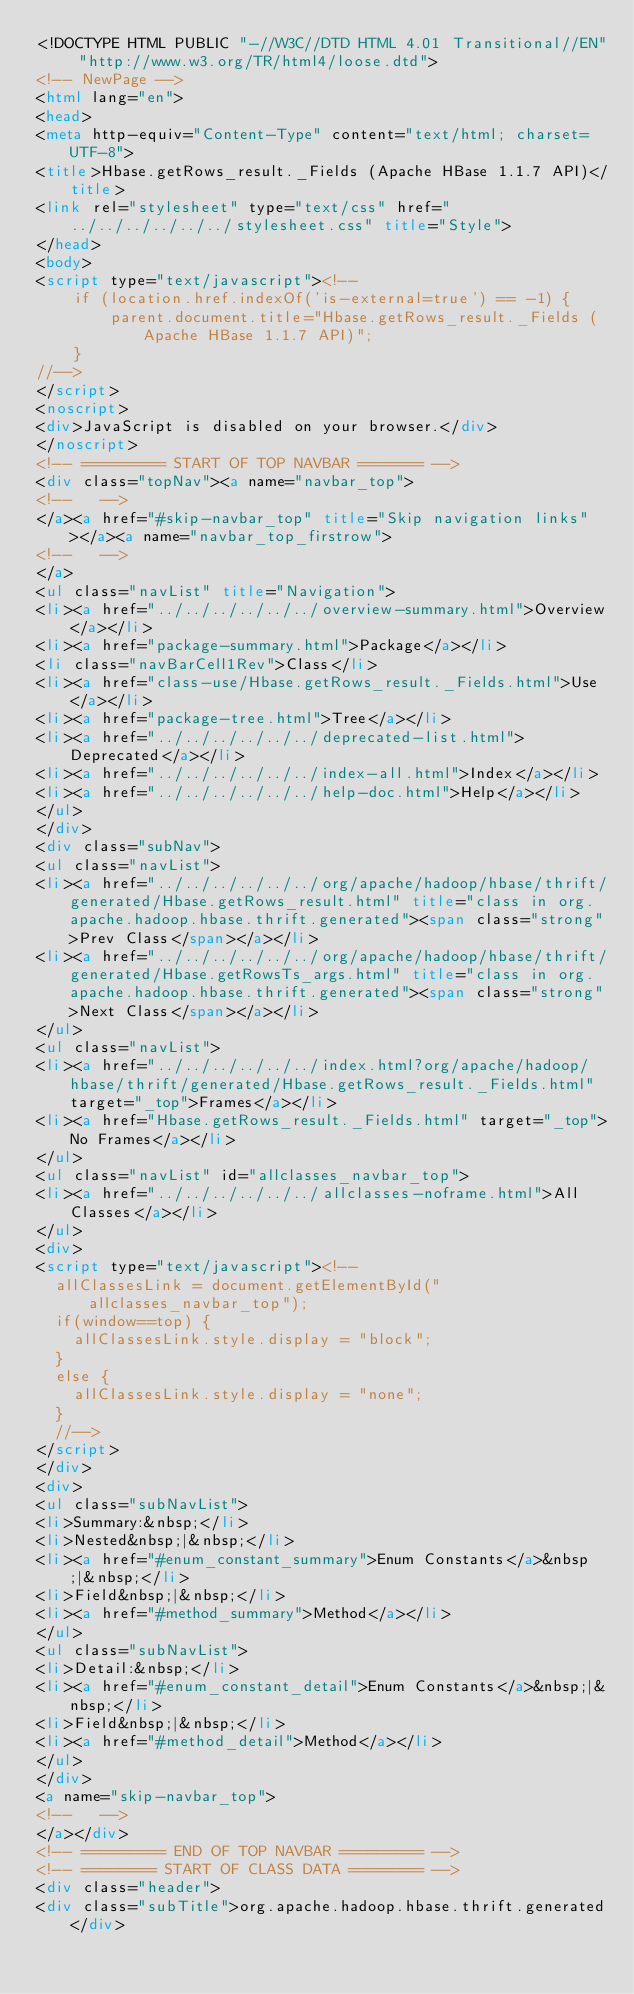<code> <loc_0><loc_0><loc_500><loc_500><_HTML_><!DOCTYPE HTML PUBLIC "-//W3C//DTD HTML 4.01 Transitional//EN" "http://www.w3.org/TR/html4/loose.dtd">
<!-- NewPage -->
<html lang="en">
<head>
<meta http-equiv="Content-Type" content="text/html; charset=UTF-8">
<title>Hbase.getRows_result._Fields (Apache HBase 1.1.7 API)</title>
<link rel="stylesheet" type="text/css" href="../../../../../../stylesheet.css" title="Style">
</head>
<body>
<script type="text/javascript"><!--
    if (location.href.indexOf('is-external=true') == -1) {
        parent.document.title="Hbase.getRows_result._Fields (Apache HBase 1.1.7 API)";
    }
//-->
</script>
<noscript>
<div>JavaScript is disabled on your browser.</div>
</noscript>
<!-- ========= START OF TOP NAVBAR ======= -->
<div class="topNav"><a name="navbar_top">
<!--   -->
</a><a href="#skip-navbar_top" title="Skip navigation links"></a><a name="navbar_top_firstrow">
<!--   -->
</a>
<ul class="navList" title="Navigation">
<li><a href="../../../../../../overview-summary.html">Overview</a></li>
<li><a href="package-summary.html">Package</a></li>
<li class="navBarCell1Rev">Class</li>
<li><a href="class-use/Hbase.getRows_result._Fields.html">Use</a></li>
<li><a href="package-tree.html">Tree</a></li>
<li><a href="../../../../../../deprecated-list.html">Deprecated</a></li>
<li><a href="../../../../../../index-all.html">Index</a></li>
<li><a href="../../../../../../help-doc.html">Help</a></li>
</ul>
</div>
<div class="subNav">
<ul class="navList">
<li><a href="../../../../../../org/apache/hadoop/hbase/thrift/generated/Hbase.getRows_result.html" title="class in org.apache.hadoop.hbase.thrift.generated"><span class="strong">Prev Class</span></a></li>
<li><a href="../../../../../../org/apache/hadoop/hbase/thrift/generated/Hbase.getRowsTs_args.html" title="class in org.apache.hadoop.hbase.thrift.generated"><span class="strong">Next Class</span></a></li>
</ul>
<ul class="navList">
<li><a href="../../../../../../index.html?org/apache/hadoop/hbase/thrift/generated/Hbase.getRows_result._Fields.html" target="_top">Frames</a></li>
<li><a href="Hbase.getRows_result._Fields.html" target="_top">No Frames</a></li>
</ul>
<ul class="navList" id="allclasses_navbar_top">
<li><a href="../../../../../../allclasses-noframe.html">All Classes</a></li>
</ul>
<div>
<script type="text/javascript"><!--
  allClassesLink = document.getElementById("allclasses_navbar_top");
  if(window==top) {
    allClassesLink.style.display = "block";
  }
  else {
    allClassesLink.style.display = "none";
  }
  //-->
</script>
</div>
<div>
<ul class="subNavList">
<li>Summary:&nbsp;</li>
<li>Nested&nbsp;|&nbsp;</li>
<li><a href="#enum_constant_summary">Enum Constants</a>&nbsp;|&nbsp;</li>
<li>Field&nbsp;|&nbsp;</li>
<li><a href="#method_summary">Method</a></li>
</ul>
<ul class="subNavList">
<li>Detail:&nbsp;</li>
<li><a href="#enum_constant_detail">Enum Constants</a>&nbsp;|&nbsp;</li>
<li>Field&nbsp;|&nbsp;</li>
<li><a href="#method_detail">Method</a></li>
</ul>
</div>
<a name="skip-navbar_top">
<!--   -->
</a></div>
<!-- ========= END OF TOP NAVBAR ========= -->
<!-- ======== START OF CLASS DATA ======== -->
<div class="header">
<div class="subTitle">org.apache.hadoop.hbase.thrift.generated</div></code> 